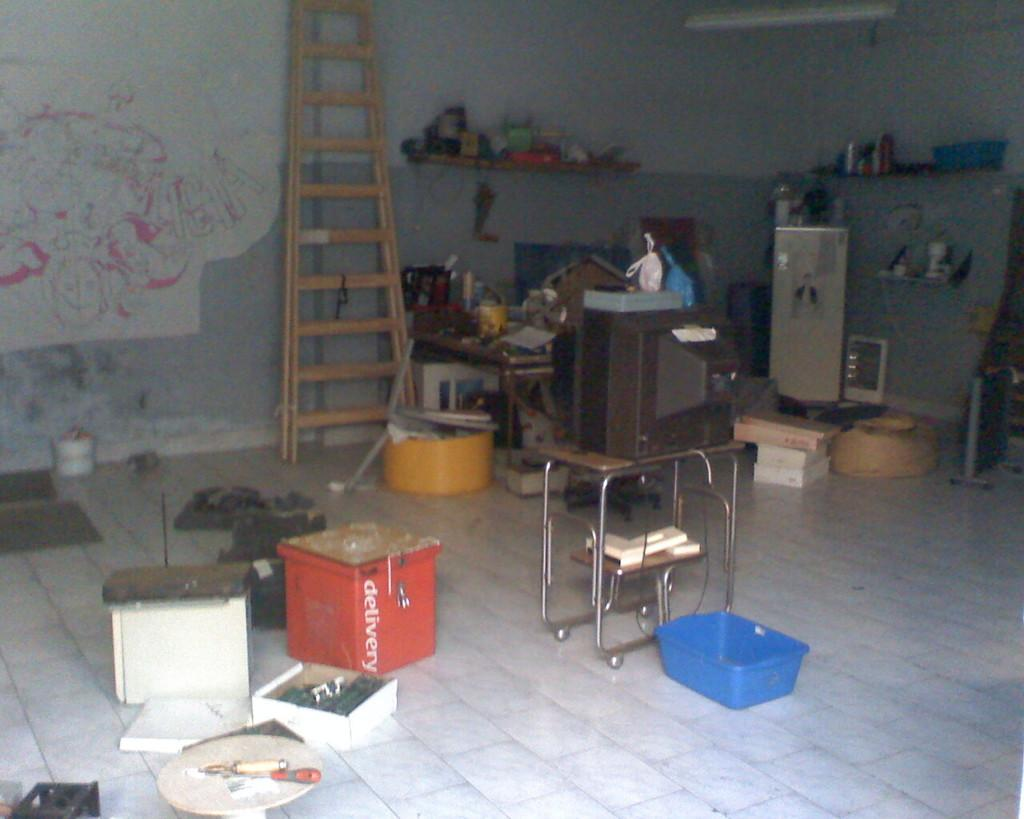What is on the floor in the image? There are objects on the floor in the image, including a television, a container stand, and a ladder. What type of electronic device is on the floor? A television is present among the objects on the floor. What is used to hold containers in the image? A container stand is among the objects on the floor. What is used for climbing or reaching high places in the image? A ladder is among the objects on the floor. What is on the wall opposite to the objects on the floor? There is a painting on the wall. What is the act of learning depicted in the painting on the wall? There is no act of learning depicted in the painting on the wall, as the painting is not described in the provided facts. 